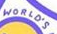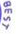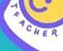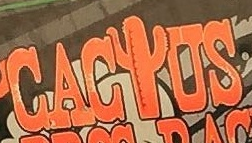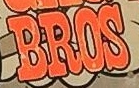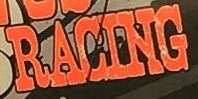Transcribe the words shown in these images in order, separated by a semicolon. WORLO'S; BEST; TEACHER; CACIUS; BROS; RACING 